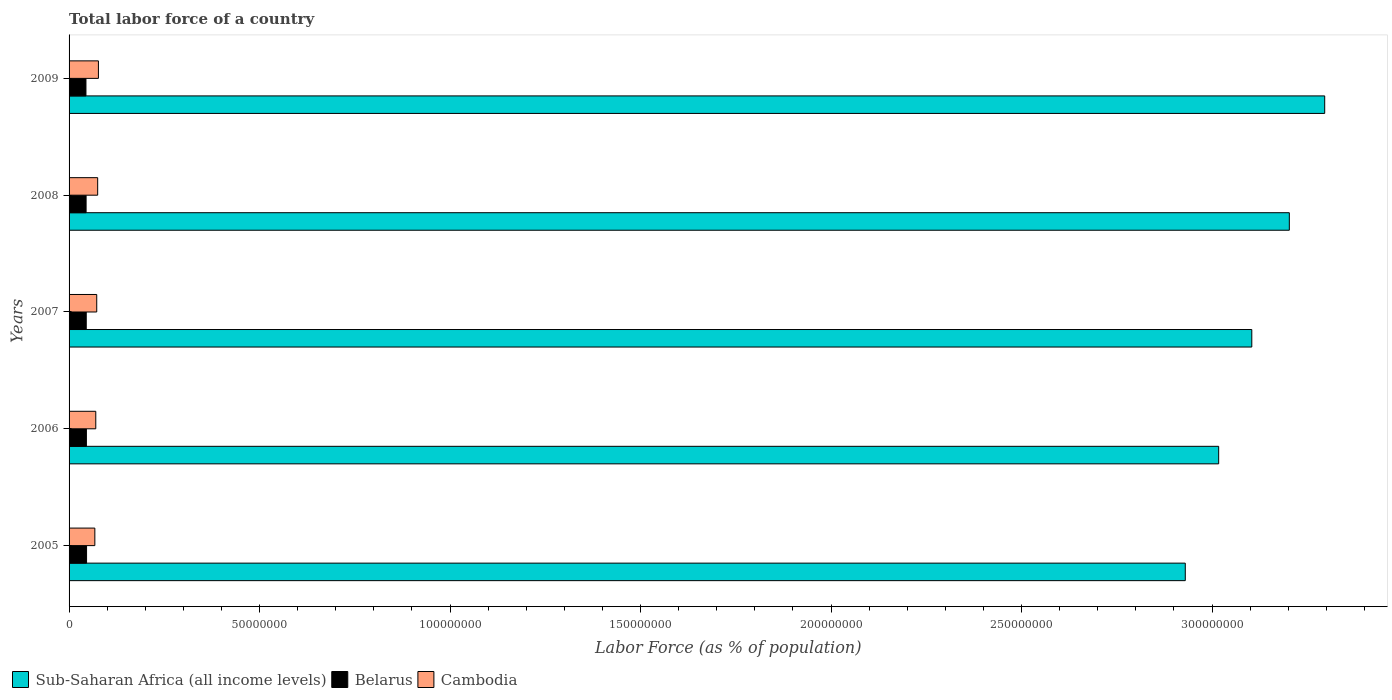How many different coloured bars are there?
Provide a short and direct response. 3. How many groups of bars are there?
Offer a terse response. 5. How many bars are there on the 3rd tick from the top?
Your answer should be compact. 3. In how many cases, is the number of bars for a given year not equal to the number of legend labels?
Offer a very short reply. 0. What is the percentage of labor force in Sub-Saharan Africa (all income levels) in 2008?
Provide a short and direct response. 3.20e+08. Across all years, what is the maximum percentage of labor force in Cambodia?
Make the answer very short. 7.70e+06. Across all years, what is the minimum percentage of labor force in Cambodia?
Offer a terse response. 6.76e+06. In which year was the percentage of labor force in Belarus maximum?
Give a very brief answer. 2005. In which year was the percentage of labor force in Belarus minimum?
Provide a succinct answer. 2009. What is the total percentage of labor force in Cambodia in the graph?
Provide a short and direct response. 3.62e+07. What is the difference between the percentage of labor force in Sub-Saharan Africa (all income levels) in 2005 and that in 2009?
Offer a terse response. -3.66e+07. What is the difference between the percentage of labor force in Belarus in 2005 and the percentage of labor force in Cambodia in 2008?
Give a very brief answer. -2.91e+06. What is the average percentage of labor force in Cambodia per year?
Provide a succinct answer. 7.25e+06. In the year 2009, what is the difference between the percentage of labor force in Sub-Saharan Africa (all income levels) and percentage of labor force in Cambodia?
Your answer should be very brief. 3.22e+08. In how many years, is the percentage of labor force in Cambodia greater than 70000000 %?
Your response must be concise. 0. What is the ratio of the percentage of labor force in Belarus in 2005 to that in 2006?
Your answer should be compact. 1.01. Is the difference between the percentage of labor force in Sub-Saharan Africa (all income levels) in 2007 and 2008 greater than the difference between the percentage of labor force in Cambodia in 2007 and 2008?
Provide a short and direct response. No. What is the difference between the highest and the second highest percentage of labor force in Belarus?
Ensure brevity in your answer.  4.41e+04. What is the difference between the highest and the lowest percentage of labor force in Cambodia?
Ensure brevity in your answer.  9.37e+05. What does the 3rd bar from the top in 2008 represents?
Offer a terse response. Sub-Saharan Africa (all income levels). What does the 3rd bar from the bottom in 2006 represents?
Ensure brevity in your answer.  Cambodia. Is it the case that in every year, the sum of the percentage of labor force in Sub-Saharan Africa (all income levels) and percentage of labor force in Cambodia is greater than the percentage of labor force in Belarus?
Give a very brief answer. Yes. Are all the bars in the graph horizontal?
Provide a short and direct response. Yes. What is the difference between two consecutive major ticks on the X-axis?
Your answer should be very brief. 5.00e+07. Does the graph contain grids?
Keep it short and to the point. No. Where does the legend appear in the graph?
Keep it short and to the point. Bottom left. What is the title of the graph?
Your answer should be compact. Total labor force of a country. Does "East Asia (developing only)" appear as one of the legend labels in the graph?
Offer a terse response. No. What is the label or title of the X-axis?
Make the answer very short. Labor Force (as % of population). What is the Labor Force (as % of population) of Sub-Saharan Africa (all income levels) in 2005?
Give a very brief answer. 2.93e+08. What is the Labor Force (as % of population) of Belarus in 2005?
Provide a succinct answer. 4.59e+06. What is the Labor Force (as % of population) in Cambodia in 2005?
Offer a terse response. 6.76e+06. What is the Labor Force (as % of population) of Sub-Saharan Africa (all income levels) in 2006?
Offer a very short reply. 3.02e+08. What is the Labor Force (as % of population) in Belarus in 2006?
Your response must be concise. 4.55e+06. What is the Labor Force (as % of population) of Cambodia in 2006?
Give a very brief answer. 7.01e+06. What is the Labor Force (as % of population) of Sub-Saharan Africa (all income levels) in 2007?
Offer a terse response. 3.10e+08. What is the Labor Force (as % of population) of Belarus in 2007?
Make the answer very short. 4.51e+06. What is the Labor Force (as % of population) in Cambodia in 2007?
Offer a very short reply. 7.26e+06. What is the Labor Force (as % of population) of Sub-Saharan Africa (all income levels) in 2008?
Your response must be concise. 3.20e+08. What is the Labor Force (as % of population) of Belarus in 2008?
Your response must be concise. 4.47e+06. What is the Labor Force (as % of population) of Cambodia in 2008?
Provide a succinct answer. 7.50e+06. What is the Labor Force (as % of population) in Sub-Saharan Africa (all income levels) in 2009?
Your answer should be compact. 3.30e+08. What is the Labor Force (as % of population) of Belarus in 2009?
Keep it short and to the point. 4.43e+06. What is the Labor Force (as % of population) in Cambodia in 2009?
Offer a terse response. 7.70e+06. Across all years, what is the maximum Labor Force (as % of population) in Sub-Saharan Africa (all income levels)?
Keep it short and to the point. 3.30e+08. Across all years, what is the maximum Labor Force (as % of population) in Belarus?
Offer a very short reply. 4.59e+06. Across all years, what is the maximum Labor Force (as % of population) of Cambodia?
Keep it short and to the point. 7.70e+06. Across all years, what is the minimum Labor Force (as % of population) of Sub-Saharan Africa (all income levels)?
Provide a short and direct response. 2.93e+08. Across all years, what is the minimum Labor Force (as % of population) of Belarus?
Make the answer very short. 4.43e+06. Across all years, what is the minimum Labor Force (as % of population) of Cambodia?
Your response must be concise. 6.76e+06. What is the total Labor Force (as % of population) of Sub-Saharan Africa (all income levels) in the graph?
Offer a very short reply. 1.55e+09. What is the total Labor Force (as % of population) of Belarus in the graph?
Provide a short and direct response. 2.25e+07. What is the total Labor Force (as % of population) in Cambodia in the graph?
Make the answer very short. 3.62e+07. What is the difference between the Labor Force (as % of population) in Sub-Saharan Africa (all income levels) in 2005 and that in 2006?
Ensure brevity in your answer.  -8.76e+06. What is the difference between the Labor Force (as % of population) in Belarus in 2005 and that in 2006?
Your answer should be compact. 4.41e+04. What is the difference between the Labor Force (as % of population) in Cambodia in 2005 and that in 2006?
Your response must be concise. -2.46e+05. What is the difference between the Labor Force (as % of population) of Sub-Saharan Africa (all income levels) in 2005 and that in 2007?
Offer a very short reply. -1.75e+07. What is the difference between the Labor Force (as % of population) of Belarus in 2005 and that in 2007?
Keep it short and to the point. 8.41e+04. What is the difference between the Labor Force (as % of population) in Cambodia in 2005 and that in 2007?
Your answer should be very brief. -4.95e+05. What is the difference between the Labor Force (as % of population) in Sub-Saharan Africa (all income levels) in 2005 and that in 2008?
Your response must be concise. -2.73e+07. What is the difference between the Labor Force (as % of population) in Belarus in 2005 and that in 2008?
Ensure brevity in your answer.  1.23e+05. What is the difference between the Labor Force (as % of population) of Cambodia in 2005 and that in 2008?
Your answer should be compact. -7.40e+05. What is the difference between the Labor Force (as % of population) of Sub-Saharan Africa (all income levels) in 2005 and that in 2009?
Your answer should be very brief. -3.66e+07. What is the difference between the Labor Force (as % of population) in Belarus in 2005 and that in 2009?
Provide a short and direct response. 1.61e+05. What is the difference between the Labor Force (as % of population) of Cambodia in 2005 and that in 2009?
Offer a terse response. -9.37e+05. What is the difference between the Labor Force (as % of population) of Sub-Saharan Africa (all income levels) in 2006 and that in 2007?
Provide a short and direct response. -8.70e+06. What is the difference between the Labor Force (as % of population) in Belarus in 2006 and that in 2007?
Give a very brief answer. 4.00e+04. What is the difference between the Labor Force (as % of population) in Cambodia in 2006 and that in 2007?
Give a very brief answer. -2.49e+05. What is the difference between the Labor Force (as % of population) of Sub-Saharan Africa (all income levels) in 2006 and that in 2008?
Your answer should be compact. -1.85e+07. What is the difference between the Labor Force (as % of population) of Belarus in 2006 and that in 2008?
Provide a succinct answer. 7.85e+04. What is the difference between the Labor Force (as % of population) in Cambodia in 2006 and that in 2008?
Provide a succinct answer. -4.94e+05. What is the difference between the Labor Force (as % of population) of Sub-Saharan Africa (all income levels) in 2006 and that in 2009?
Your response must be concise. -2.78e+07. What is the difference between the Labor Force (as % of population) of Belarus in 2006 and that in 2009?
Provide a short and direct response. 1.17e+05. What is the difference between the Labor Force (as % of population) of Cambodia in 2006 and that in 2009?
Ensure brevity in your answer.  -6.91e+05. What is the difference between the Labor Force (as % of population) of Sub-Saharan Africa (all income levels) in 2007 and that in 2008?
Your response must be concise. -9.85e+06. What is the difference between the Labor Force (as % of population) of Belarus in 2007 and that in 2008?
Provide a succinct answer. 3.85e+04. What is the difference between the Labor Force (as % of population) in Cambodia in 2007 and that in 2008?
Your response must be concise. -2.45e+05. What is the difference between the Labor Force (as % of population) in Sub-Saharan Africa (all income levels) in 2007 and that in 2009?
Your answer should be very brief. -1.91e+07. What is the difference between the Labor Force (as % of population) in Belarus in 2007 and that in 2009?
Make the answer very short. 7.69e+04. What is the difference between the Labor Force (as % of population) of Cambodia in 2007 and that in 2009?
Give a very brief answer. -4.42e+05. What is the difference between the Labor Force (as % of population) of Sub-Saharan Africa (all income levels) in 2008 and that in 2009?
Keep it short and to the point. -9.28e+06. What is the difference between the Labor Force (as % of population) in Belarus in 2008 and that in 2009?
Offer a very short reply. 3.84e+04. What is the difference between the Labor Force (as % of population) in Cambodia in 2008 and that in 2009?
Your answer should be compact. -1.97e+05. What is the difference between the Labor Force (as % of population) in Sub-Saharan Africa (all income levels) in 2005 and the Labor Force (as % of population) in Belarus in 2006?
Make the answer very short. 2.88e+08. What is the difference between the Labor Force (as % of population) of Sub-Saharan Africa (all income levels) in 2005 and the Labor Force (as % of population) of Cambodia in 2006?
Ensure brevity in your answer.  2.86e+08. What is the difference between the Labor Force (as % of population) in Belarus in 2005 and the Labor Force (as % of population) in Cambodia in 2006?
Make the answer very short. -2.42e+06. What is the difference between the Labor Force (as % of population) in Sub-Saharan Africa (all income levels) in 2005 and the Labor Force (as % of population) in Belarus in 2007?
Keep it short and to the point. 2.88e+08. What is the difference between the Labor Force (as % of population) in Sub-Saharan Africa (all income levels) in 2005 and the Labor Force (as % of population) in Cambodia in 2007?
Keep it short and to the point. 2.86e+08. What is the difference between the Labor Force (as % of population) of Belarus in 2005 and the Labor Force (as % of population) of Cambodia in 2007?
Your answer should be very brief. -2.67e+06. What is the difference between the Labor Force (as % of population) in Sub-Saharan Africa (all income levels) in 2005 and the Labor Force (as % of population) in Belarus in 2008?
Provide a short and direct response. 2.88e+08. What is the difference between the Labor Force (as % of population) of Sub-Saharan Africa (all income levels) in 2005 and the Labor Force (as % of population) of Cambodia in 2008?
Provide a short and direct response. 2.85e+08. What is the difference between the Labor Force (as % of population) in Belarus in 2005 and the Labor Force (as % of population) in Cambodia in 2008?
Offer a very short reply. -2.91e+06. What is the difference between the Labor Force (as % of population) in Sub-Saharan Africa (all income levels) in 2005 and the Labor Force (as % of population) in Belarus in 2009?
Give a very brief answer. 2.89e+08. What is the difference between the Labor Force (as % of population) of Sub-Saharan Africa (all income levels) in 2005 and the Labor Force (as % of population) of Cambodia in 2009?
Make the answer very short. 2.85e+08. What is the difference between the Labor Force (as % of population) of Belarus in 2005 and the Labor Force (as % of population) of Cambodia in 2009?
Make the answer very short. -3.11e+06. What is the difference between the Labor Force (as % of population) of Sub-Saharan Africa (all income levels) in 2006 and the Labor Force (as % of population) of Belarus in 2007?
Offer a terse response. 2.97e+08. What is the difference between the Labor Force (as % of population) of Sub-Saharan Africa (all income levels) in 2006 and the Labor Force (as % of population) of Cambodia in 2007?
Provide a short and direct response. 2.94e+08. What is the difference between the Labor Force (as % of population) of Belarus in 2006 and the Labor Force (as % of population) of Cambodia in 2007?
Your response must be concise. -2.71e+06. What is the difference between the Labor Force (as % of population) in Sub-Saharan Africa (all income levels) in 2006 and the Labor Force (as % of population) in Belarus in 2008?
Your answer should be very brief. 2.97e+08. What is the difference between the Labor Force (as % of population) in Sub-Saharan Africa (all income levels) in 2006 and the Labor Force (as % of population) in Cambodia in 2008?
Your answer should be compact. 2.94e+08. What is the difference between the Labor Force (as % of population) in Belarus in 2006 and the Labor Force (as % of population) in Cambodia in 2008?
Offer a very short reply. -2.96e+06. What is the difference between the Labor Force (as % of population) of Sub-Saharan Africa (all income levels) in 2006 and the Labor Force (as % of population) of Belarus in 2009?
Provide a succinct answer. 2.97e+08. What is the difference between the Labor Force (as % of population) of Sub-Saharan Africa (all income levels) in 2006 and the Labor Force (as % of population) of Cambodia in 2009?
Provide a short and direct response. 2.94e+08. What is the difference between the Labor Force (as % of population) in Belarus in 2006 and the Labor Force (as % of population) in Cambodia in 2009?
Your answer should be very brief. -3.16e+06. What is the difference between the Labor Force (as % of population) of Sub-Saharan Africa (all income levels) in 2007 and the Labor Force (as % of population) of Belarus in 2008?
Offer a terse response. 3.06e+08. What is the difference between the Labor Force (as % of population) in Sub-Saharan Africa (all income levels) in 2007 and the Labor Force (as % of population) in Cambodia in 2008?
Provide a succinct answer. 3.03e+08. What is the difference between the Labor Force (as % of population) in Belarus in 2007 and the Labor Force (as % of population) in Cambodia in 2008?
Make the answer very short. -3.00e+06. What is the difference between the Labor Force (as % of population) of Sub-Saharan Africa (all income levels) in 2007 and the Labor Force (as % of population) of Belarus in 2009?
Ensure brevity in your answer.  3.06e+08. What is the difference between the Labor Force (as % of population) of Sub-Saharan Africa (all income levels) in 2007 and the Labor Force (as % of population) of Cambodia in 2009?
Your response must be concise. 3.03e+08. What is the difference between the Labor Force (as % of population) of Belarus in 2007 and the Labor Force (as % of population) of Cambodia in 2009?
Keep it short and to the point. -3.20e+06. What is the difference between the Labor Force (as % of population) of Sub-Saharan Africa (all income levels) in 2008 and the Labor Force (as % of population) of Belarus in 2009?
Provide a succinct answer. 3.16e+08. What is the difference between the Labor Force (as % of population) in Sub-Saharan Africa (all income levels) in 2008 and the Labor Force (as % of population) in Cambodia in 2009?
Keep it short and to the point. 3.13e+08. What is the difference between the Labor Force (as % of population) in Belarus in 2008 and the Labor Force (as % of population) in Cambodia in 2009?
Your response must be concise. -3.23e+06. What is the average Labor Force (as % of population) in Sub-Saharan Africa (all income levels) per year?
Provide a short and direct response. 3.11e+08. What is the average Labor Force (as % of population) of Belarus per year?
Make the answer very short. 4.51e+06. What is the average Labor Force (as % of population) of Cambodia per year?
Your answer should be compact. 7.25e+06. In the year 2005, what is the difference between the Labor Force (as % of population) in Sub-Saharan Africa (all income levels) and Labor Force (as % of population) in Belarus?
Your answer should be compact. 2.88e+08. In the year 2005, what is the difference between the Labor Force (as % of population) of Sub-Saharan Africa (all income levels) and Labor Force (as % of population) of Cambodia?
Keep it short and to the point. 2.86e+08. In the year 2005, what is the difference between the Labor Force (as % of population) of Belarus and Labor Force (as % of population) of Cambodia?
Your answer should be very brief. -2.17e+06. In the year 2006, what is the difference between the Labor Force (as % of population) of Sub-Saharan Africa (all income levels) and Labor Force (as % of population) of Belarus?
Offer a very short reply. 2.97e+08. In the year 2006, what is the difference between the Labor Force (as % of population) in Sub-Saharan Africa (all income levels) and Labor Force (as % of population) in Cambodia?
Your response must be concise. 2.95e+08. In the year 2006, what is the difference between the Labor Force (as % of population) of Belarus and Labor Force (as % of population) of Cambodia?
Provide a succinct answer. -2.46e+06. In the year 2007, what is the difference between the Labor Force (as % of population) in Sub-Saharan Africa (all income levels) and Labor Force (as % of population) in Belarus?
Your answer should be compact. 3.06e+08. In the year 2007, what is the difference between the Labor Force (as % of population) in Sub-Saharan Africa (all income levels) and Labor Force (as % of population) in Cambodia?
Your answer should be compact. 3.03e+08. In the year 2007, what is the difference between the Labor Force (as % of population) of Belarus and Labor Force (as % of population) of Cambodia?
Keep it short and to the point. -2.75e+06. In the year 2008, what is the difference between the Labor Force (as % of population) of Sub-Saharan Africa (all income levels) and Labor Force (as % of population) of Belarus?
Provide a short and direct response. 3.16e+08. In the year 2008, what is the difference between the Labor Force (as % of population) of Sub-Saharan Africa (all income levels) and Labor Force (as % of population) of Cambodia?
Provide a short and direct response. 3.13e+08. In the year 2008, what is the difference between the Labor Force (as % of population) in Belarus and Labor Force (as % of population) in Cambodia?
Provide a succinct answer. -3.04e+06. In the year 2009, what is the difference between the Labor Force (as % of population) of Sub-Saharan Africa (all income levels) and Labor Force (as % of population) of Belarus?
Give a very brief answer. 3.25e+08. In the year 2009, what is the difference between the Labor Force (as % of population) of Sub-Saharan Africa (all income levels) and Labor Force (as % of population) of Cambodia?
Ensure brevity in your answer.  3.22e+08. In the year 2009, what is the difference between the Labor Force (as % of population) in Belarus and Labor Force (as % of population) in Cambodia?
Give a very brief answer. -3.27e+06. What is the ratio of the Labor Force (as % of population) in Sub-Saharan Africa (all income levels) in 2005 to that in 2006?
Provide a succinct answer. 0.97. What is the ratio of the Labor Force (as % of population) in Belarus in 2005 to that in 2006?
Your answer should be very brief. 1.01. What is the ratio of the Labor Force (as % of population) of Cambodia in 2005 to that in 2006?
Give a very brief answer. 0.96. What is the ratio of the Labor Force (as % of population) of Sub-Saharan Africa (all income levels) in 2005 to that in 2007?
Ensure brevity in your answer.  0.94. What is the ratio of the Labor Force (as % of population) in Belarus in 2005 to that in 2007?
Your answer should be compact. 1.02. What is the ratio of the Labor Force (as % of population) of Cambodia in 2005 to that in 2007?
Your answer should be very brief. 0.93. What is the ratio of the Labor Force (as % of population) in Sub-Saharan Africa (all income levels) in 2005 to that in 2008?
Your answer should be very brief. 0.91. What is the ratio of the Labor Force (as % of population) in Belarus in 2005 to that in 2008?
Your response must be concise. 1.03. What is the ratio of the Labor Force (as % of population) in Cambodia in 2005 to that in 2008?
Ensure brevity in your answer.  0.9. What is the ratio of the Labor Force (as % of population) in Sub-Saharan Africa (all income levels) in 2005 to that in 2009?
Give a very brief answer. 0.89. What is the ratio of the Labor Force (as % of population) of Belarus in 2005 to that in 2009?
Keep it short and to the point. 1.04. What is the ratio of the Labor Force (as % of population) of Cambodia in 2005 to that in 2009?
Your answer should be compact. 0.88. What is the ratio of the Labor Force (as % of population) in Belarus in 2006 to that in 2007?
Your response must be concise. 1.01. What is the ratio of the Labor Force (as % of population) of Cambodia in 2006 to that in 2007?
Ensure brevity in your answer.  0.97. What is the ratio of the Labor Force (as % of population) of Sub-Saharan Africa (all income levels) in 2006 to that in 2008?
Your answer should be compact. 0.94. What is the ratio of the Labor Force (as % of population) of Belarus in 2006 to that in 2008?
Offer a terse response. 1.02. What is the ratio of the Labor Force (as % of population) in Cambodia in 2006 to that in 2008?
Your answer should be very brief. 0.93. What is the ratio of the Labor Force (as % of population) in Sub-Saharan Africa (all income levels) in 2006 to that in 2009?
Your answer should be compact. 0.92. What is the ratio of the Labor Force (as % of population) of Belarus in 2006 to that in 2009?
Provide a succinct answer. 1.03. What is the ratio of the Labor Force (as % of population) of Cambodia in 2006 to that in 2009?
Your response must be concise. 0.91. What is the ratio of the Labor Force (as % of population) in Sub-Saharan Africa (all income levels) in 2007 to that in 2008?
Your answer should be compact. 0.97. What is the ratio of the Labor Force (as % of population) of Belarus in 2007 to that in 2008?
Ensure brevity in your answer.  1.01. What is the ratio of the Labor Force (as % of population) in Cambodia in 2007 to that in 2008?
Provide a short and direct response. 0.97. What is the ratio of the Labor Force (as % of population) in Sub-Saharan Africa (all income levels) in 2007 to that in 2009?
Provide a short and direct response. 0.94. What is the ratio of the Labor Force (as % of population) of Belarus in 2007 to that in 2009?
Give a very brief answer. 1.02. What is the ratio of the Labor Force (as % of population) in Cambodia in 2007 to that in 2009?
Provide a short and direct response. 0.94. What is the ratio of the Labor Force (as % of population) of Sub-Saharan Africa (all income levels) in 2008 to that in 2009?
Your answer should be compact. 0.97. What is the ratio of the Labor Force (as % of population) in Belarus in 2008 to that in 2009?
Your response must be concise. 1.01. What is the ratio of the Labor Force (as % of population) of Cambodia in 2008 to that in 2009?
Offer a very short reply. 0.97. What is the difference between the highest and the second highest Labor Force (as % of population) of Sub-Saharan Africa (all income levels)?
Give a very brief answer. 9.28e+06. What is the difference between the highest and the second highest Labor Force (as % of population) of Belarus?
Offer a terse response. 4.41e+04. What is the difference between the highest and the second highest Labor Force (as % of population) in Cambodia?
Offer a very short reply. 1.97e+05. What is the difference between the highest and the lowest Labor Force (as % of population) in Sub-Saharan Africa (all income levels)?
Offer a very short reply. 3.66e+07. What is the difference between the highest and the lowest Labor Force (as % of population) in Belarus?
Your answer should be compact. 1.61e+05. What is the difference between the highest and the lowest Labor Force (as % of population) of Cambodia?
Give a very brief answer. 9.37e+05. 